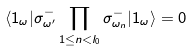Convert formula to latex. <formula><loc_0><loc_0><loc_500><loc_500>\langle 1 _ { \omega } | \sigma ^ { - } _ { \omega ^ { \prime } } \prod _ { 1 \leq n < l _ { 0 } } \sigma ^ { - } _ { \omega _ { n } } | 1 _ { \omega } \rangle = 0</formula> 